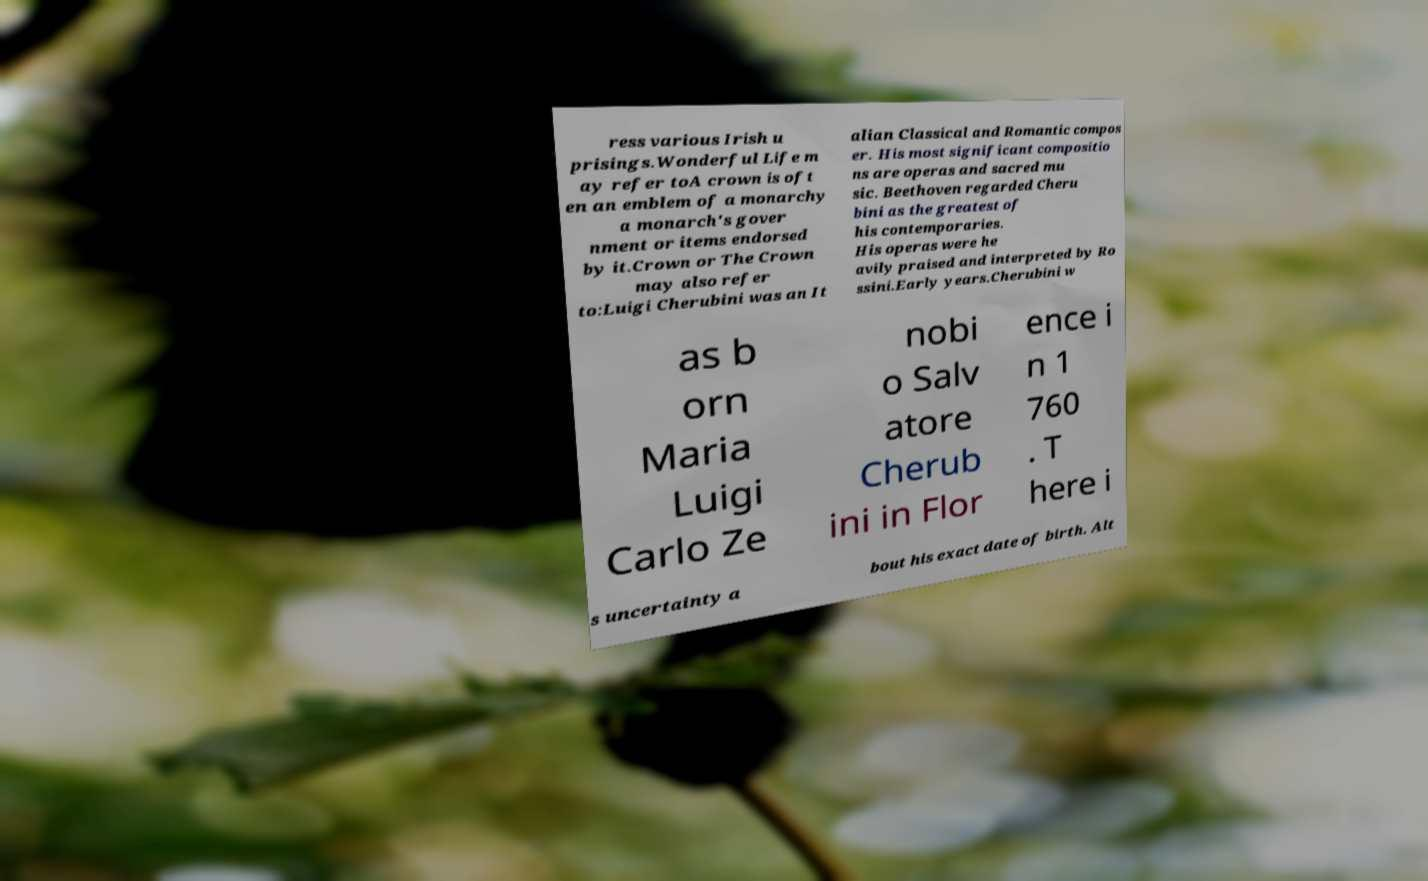Can you read and provide the text displayed in the image?This photo seems to have some interesting text. Can you extract and type it out for me? ress various Irish u prisings.Wonderful Life m ay refer toA crown is oft en an emblem of a monarchy a monarch's gover nment or items endorsed by it.Crown or The Crown may also refer to:Luigi Cherubini was an It alian Classical and Romantic compos er. His most significant compositio ns are operas and sacred mu sic. Beethoven regarded Cheru bini as the greatest of his contemporaries. His operas were he avily praised and interpreted by Ro ssini.Early years.Cherubini w as b orn Maria Luigi Carlo Ze nobi o Salv atore Cherub ini in Flor ence i n 1 760 . T here i s uncertainty a bout his exact date of birth. Alt 